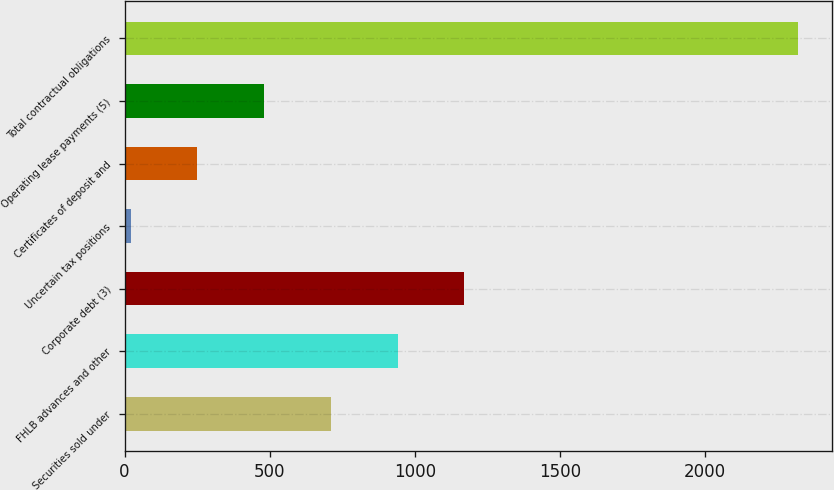Convert chart to OTSL. <chart><loc_0><loc_0><loc_500><loc_500><bar_chart><fcel>Securities sold under<fcel>FHLB advances and other<fcel>Corporate debt (3)<fcel>Uncertain tax positions<fcel>Certificates of deposit and<fcel>Operating lease payments (5)<fcel>Total contractual obligations<nl><fcel>710.46<fcel>940.38<fcel>1170.3<fcel>20.7<fcel>250.62<fcel>480.54<fcel>2319.9<nl></chart> 